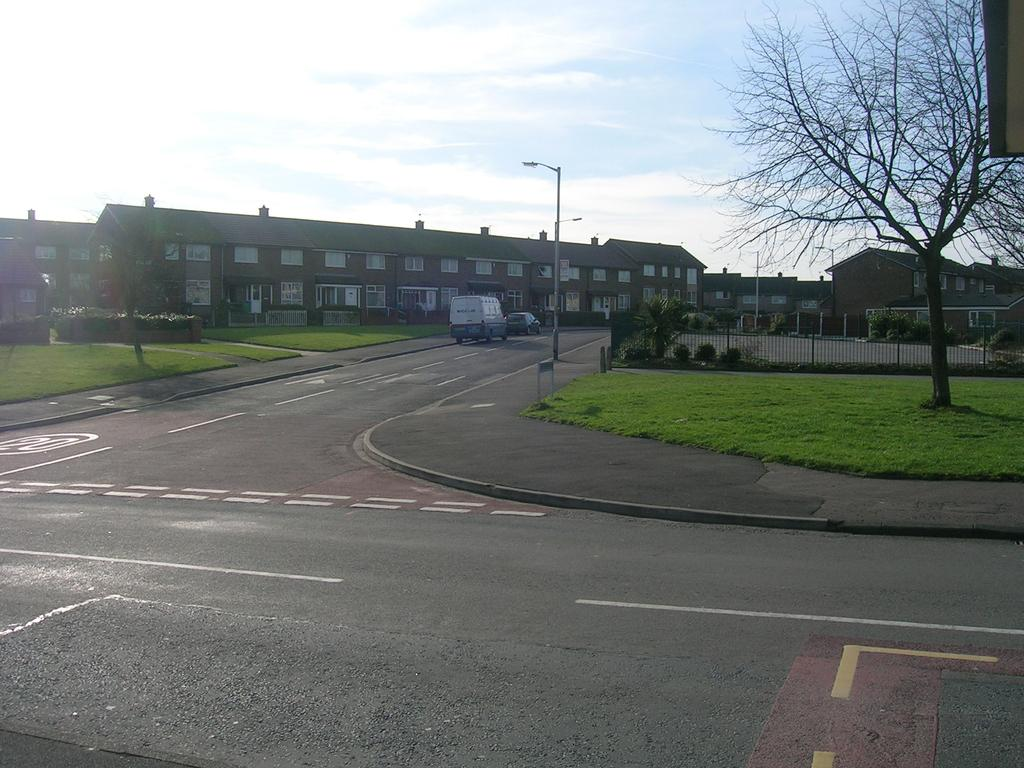What can be seen on the road in the image? There are vehicles on the road in the image. What is visible in the background of the image? Buildings with windows, a fence, plants, grass, a light pole, and a tree can be seen in the background. How would you describe the weather in the image? The sky is cloudy in the image, suggesting a partly cloudy or overcast day. Where is the paper located in the image? There is no paper present in the image. Can you describe the room in which the vehicles are parked? The image does not show a room; it is an outdoor scene with vehicles on the road and various background elements. 